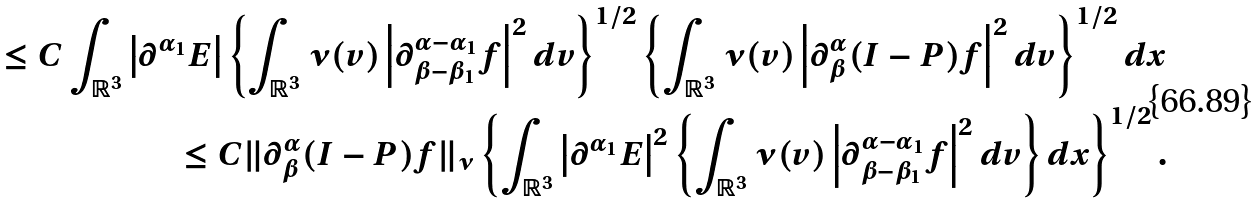Convert formula to latex. <formula><loc_0><loc_0><loc_500><loc_500>\leq C \int _ { \mathbb { R } ^ { 3 } } \left | \partial ^ { \alpha _ { 1 } } E \right | \left \{ \int _ { \mathbb { R } ^ { 3 } } \nu ( v ) \left | \partial _ { \beta - \beta _ { 1 } } ^ { \alpha - \alpha _ { 1 } } f \right | ^ { 2 } d v \right \} ^ { 1 / 2 } \left \{ \int _ { \mathbb { R } ^ { 3 } } \nu ( v ) \left | \partial _ { \beta } ^ { \alpha } ( { I - P } ) f \right | ^ { 2 } d v \right \} ^ { 1 / 2 } d x \\ \leq C \| \partial _ { \beta } ^ { \alpha } ( { I - P } ) f \| _ { \nu } \left \{ \int _ { \mathbb { R } ^ { 3 } } \left | \partial ^ { \alpha _ { 1 } } E \right | ^ { 2 } \left \{ \int _ { \mathbb { R } ^ { 3 } } \nu ( v ) \left | \partial _ { \beta - \beta _ { 1 } } ^ { \alpha - \alpha _ { 1 } } f \right | ^ { 2 } d v \right \} d x \right \} ^ { 1 / 2 } .</formula> 